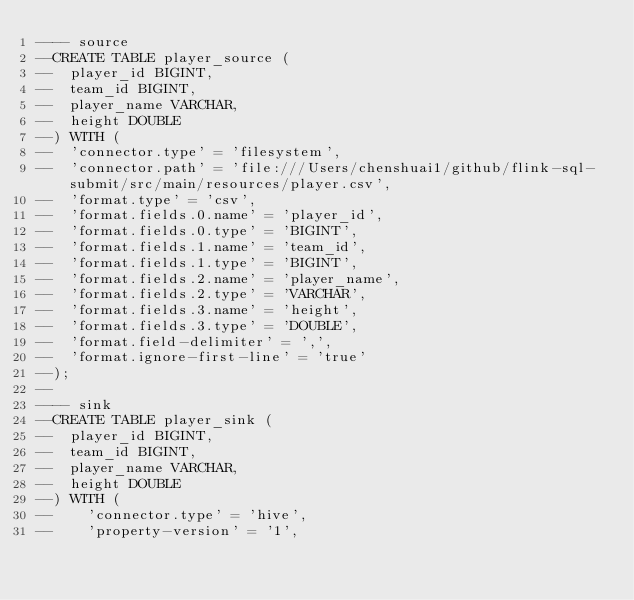Convert code to text. <code><loc_0><loc_0><loc_500><loc_500><_SQL_>---- source
--CREATE TABLE player_source (
--  player_id BIGINT,
--  team_id BIGINT,
--  player_name VARCHAR,
--  height DOUBLE
--) WITH (
--  'connector.type' = 'filesystem',
--  'connector.path' = 'file:///Users/chenshuai1/github/flink-sql-submit/src/main/resources/player.csv',
--  'format.type' = 'csv',
--  'format.fields.0.name' = 'player_id',
--  'format.fields.0.type' = 'BIGINT',
--  'format.fields.1.name' = 'team_id',
--  'format.fields.1.type' = 'BIGINT',
--  'format.fields.2.name' = 'player_name',
--  'format.fields.2.type' = 'VARCHAR',
--  'format.fields.3.name' = 'height',
--  'format.fields.3.type' = 'DOUBLE',
--  'format.field-delimiter' = ',',
--  'format.ignore-first-line' = 'true'
--);
--
---- sink
--CREATE TABLE player_sink (
--  player_id BIGINT,
--  team_id BIGINT,
--  player_name VARCHAR,
--  height DOUBLE
--) WITH (
--    'connector.type' = 'hive',
--    'property-version' = '1',</code> 